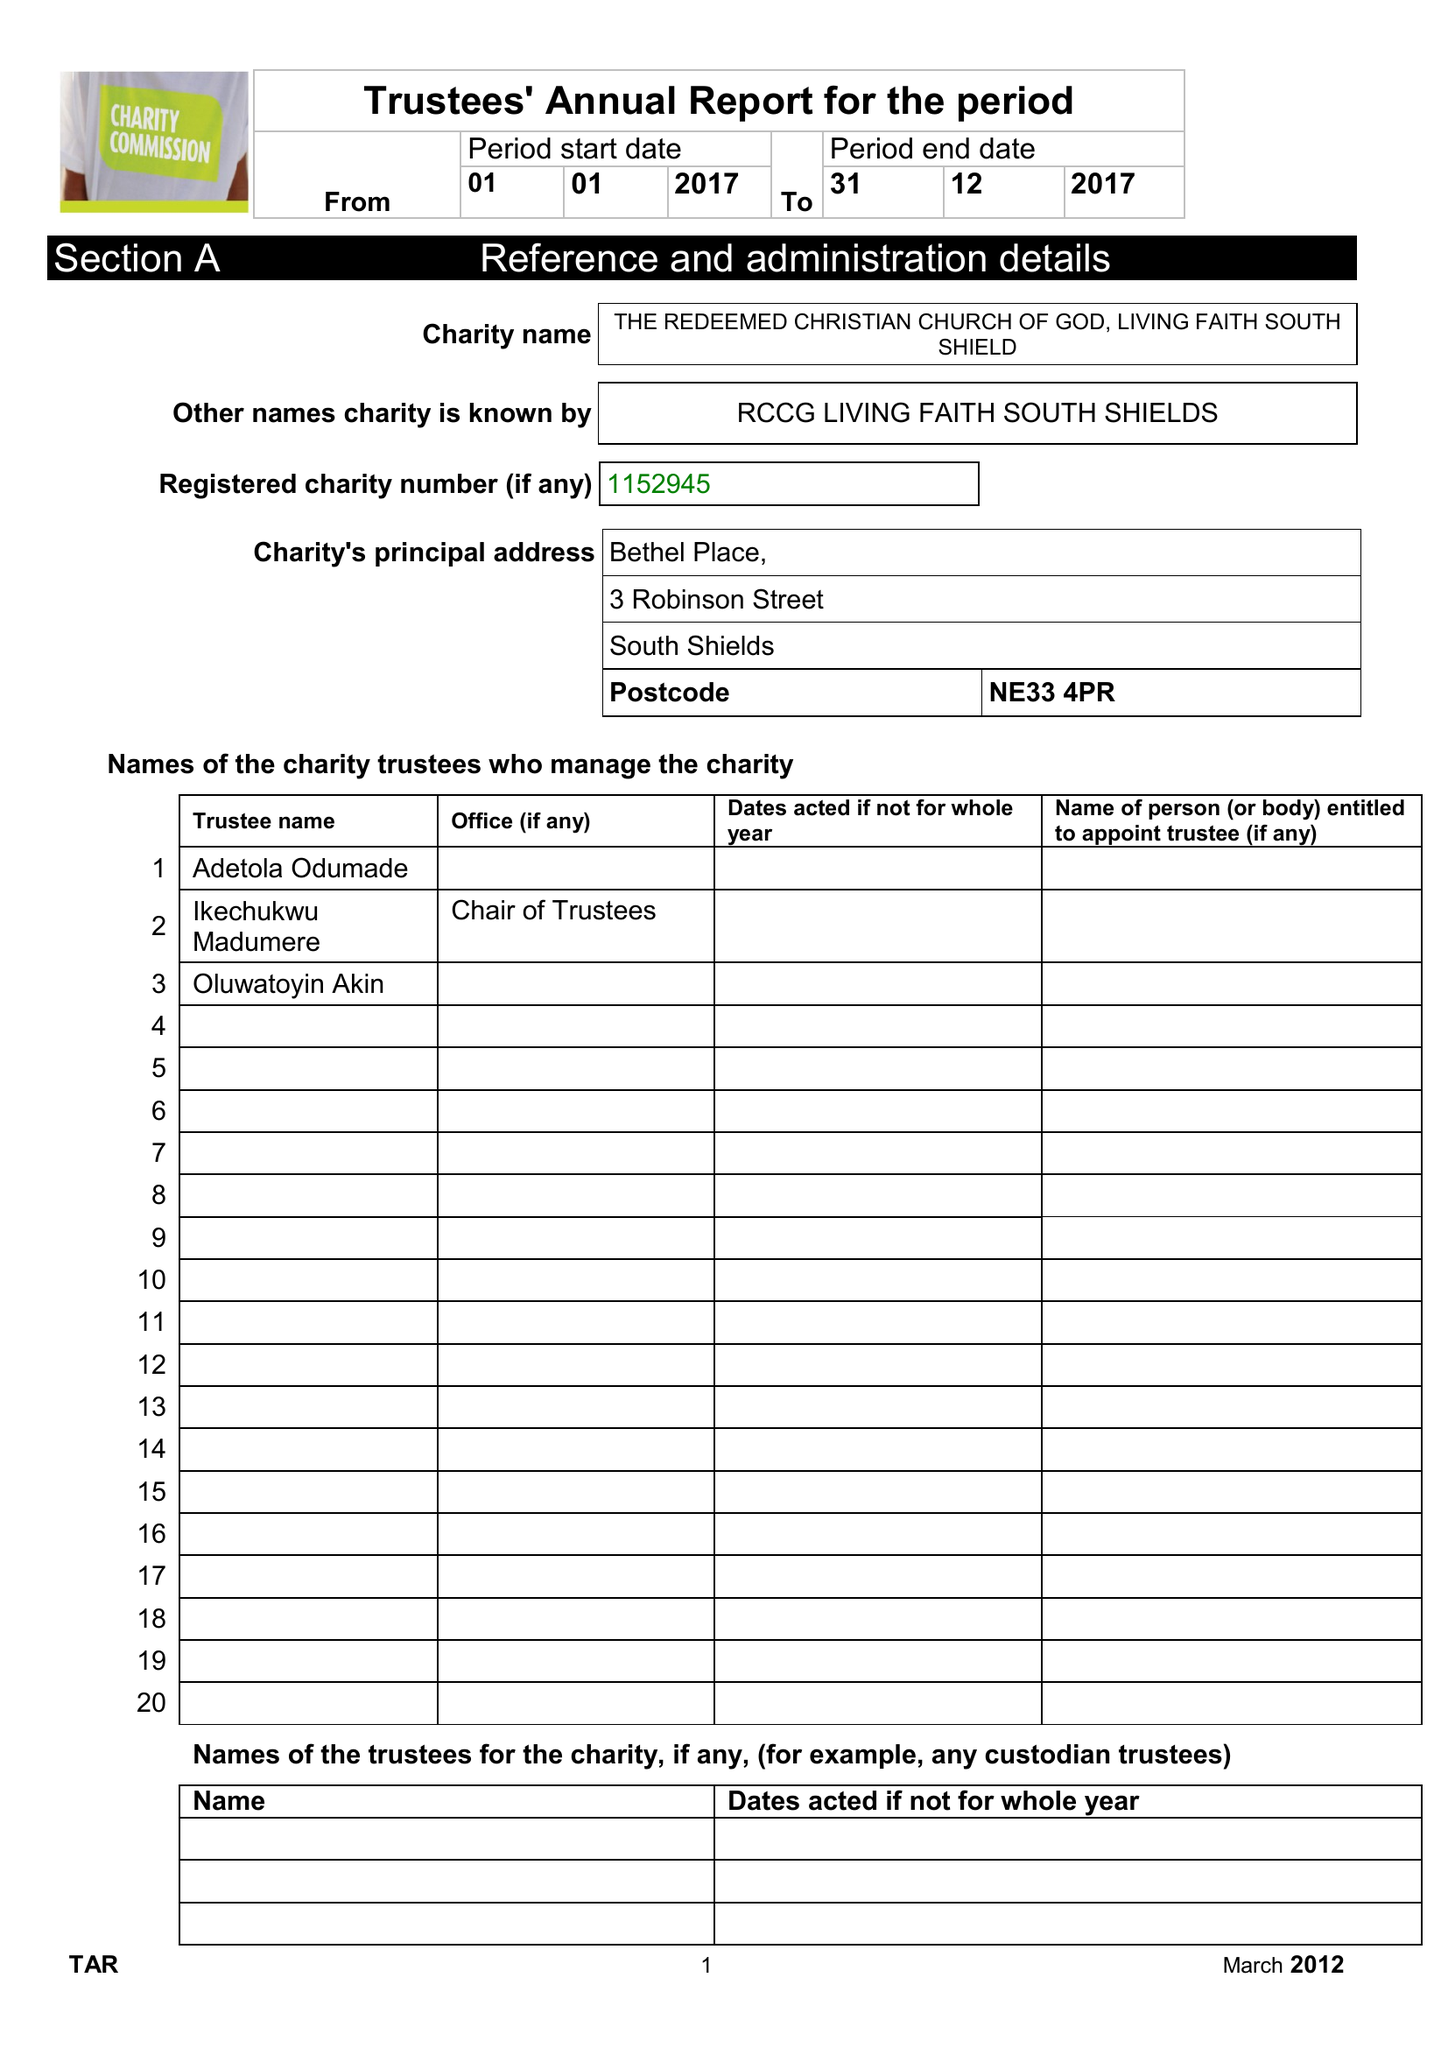What is the value for the charity_name?
Answer the question using a single word or phrase. The Redeemed Christian Church Of God, Living Faith South Shields 